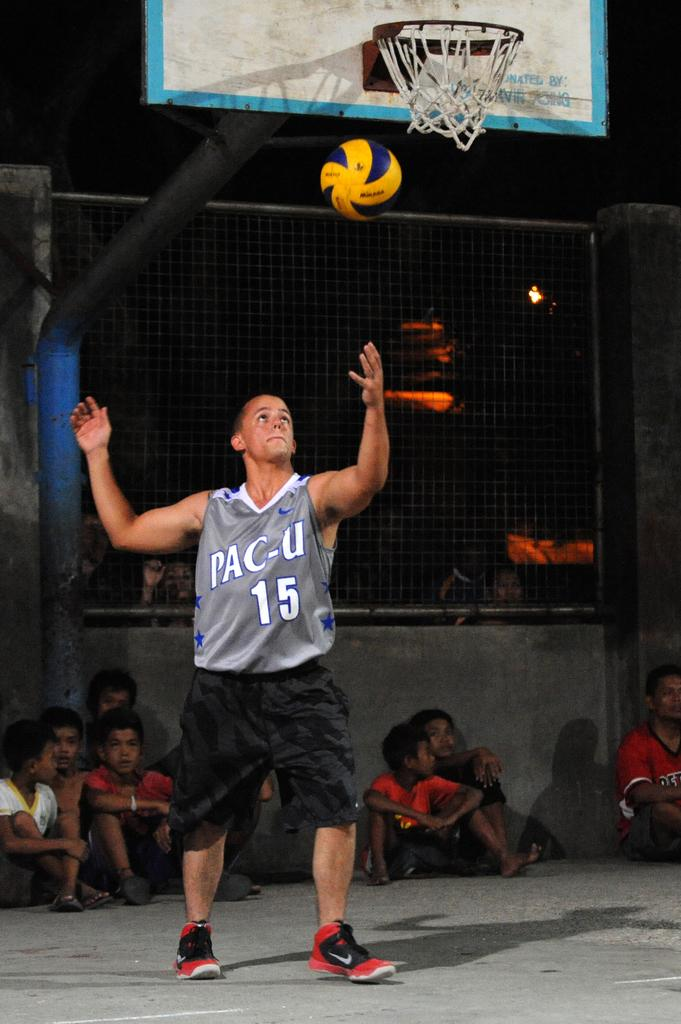<image>
Create a compact narrative representing the image presented. a volleball player wearing a jersey with PAC-U on it 